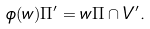Convert formula to latex. <formula><loc_0><loc_0><loc_500><loc_500>\phi ( w ) \Pi ^ { \prime } = w \Pi \cap V ^ { \prime } .</formula> 